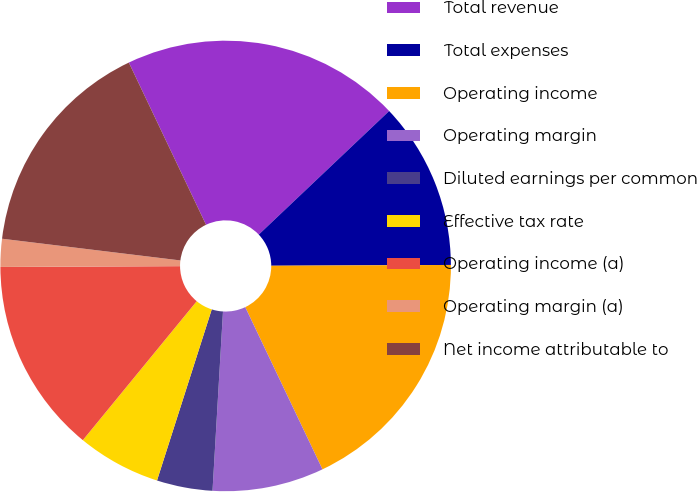Convert chart to OTSL. <chart><loc_0><loc_0><loc_500><loc_500><pie_chart><fcel>Total revenue<fcel>Total expenses<fcel>Operating income<fcel>Operating margin<fcel>Diluted earnings per common<fcel>Effective tax rate<fcel>Operating income (a)<fcel>Operating margin (a)<fcel>Net income attributable to<nl><fcel>20.0%<fcel>12.0%<fcel>18.0%<fcel>8.0%<fcel>4.0%<fcel>6.0%<fcel>14.0%<fcel>2.0%<fcel>16.0%<nl></chart> 